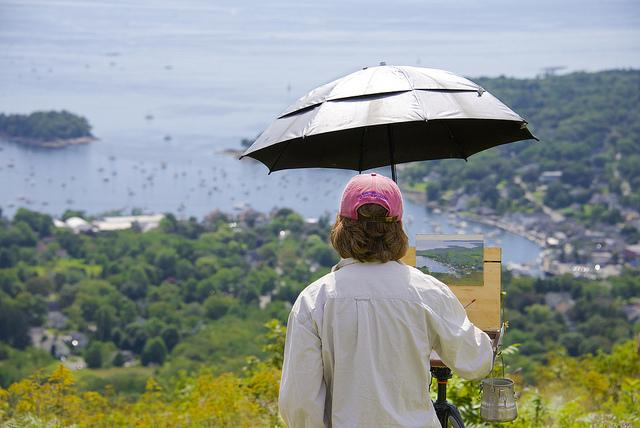What is in the metal tin?

Choices:
A) water
B) erasers
C) paint
D) snacks water 